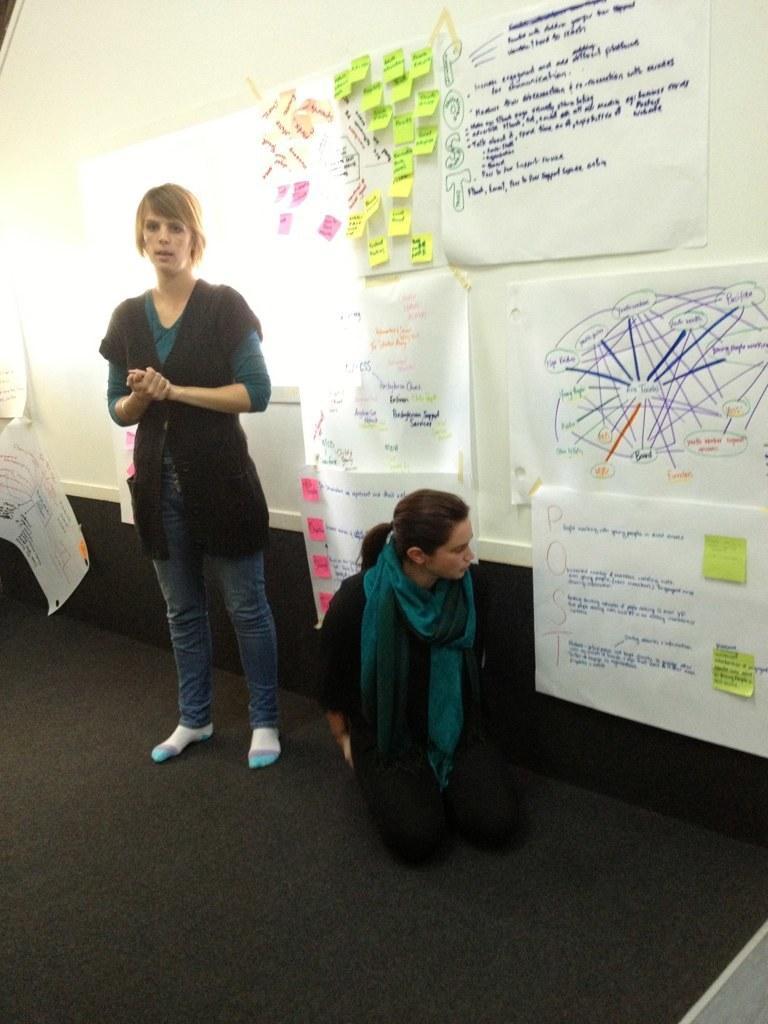Describe this image in one or two sentences. In the center of the image we can see woman sitting on the ground. On the left side of the image we can see charts and woman standing on the ground. In the background we can see wall and charts pasted to the wall. 